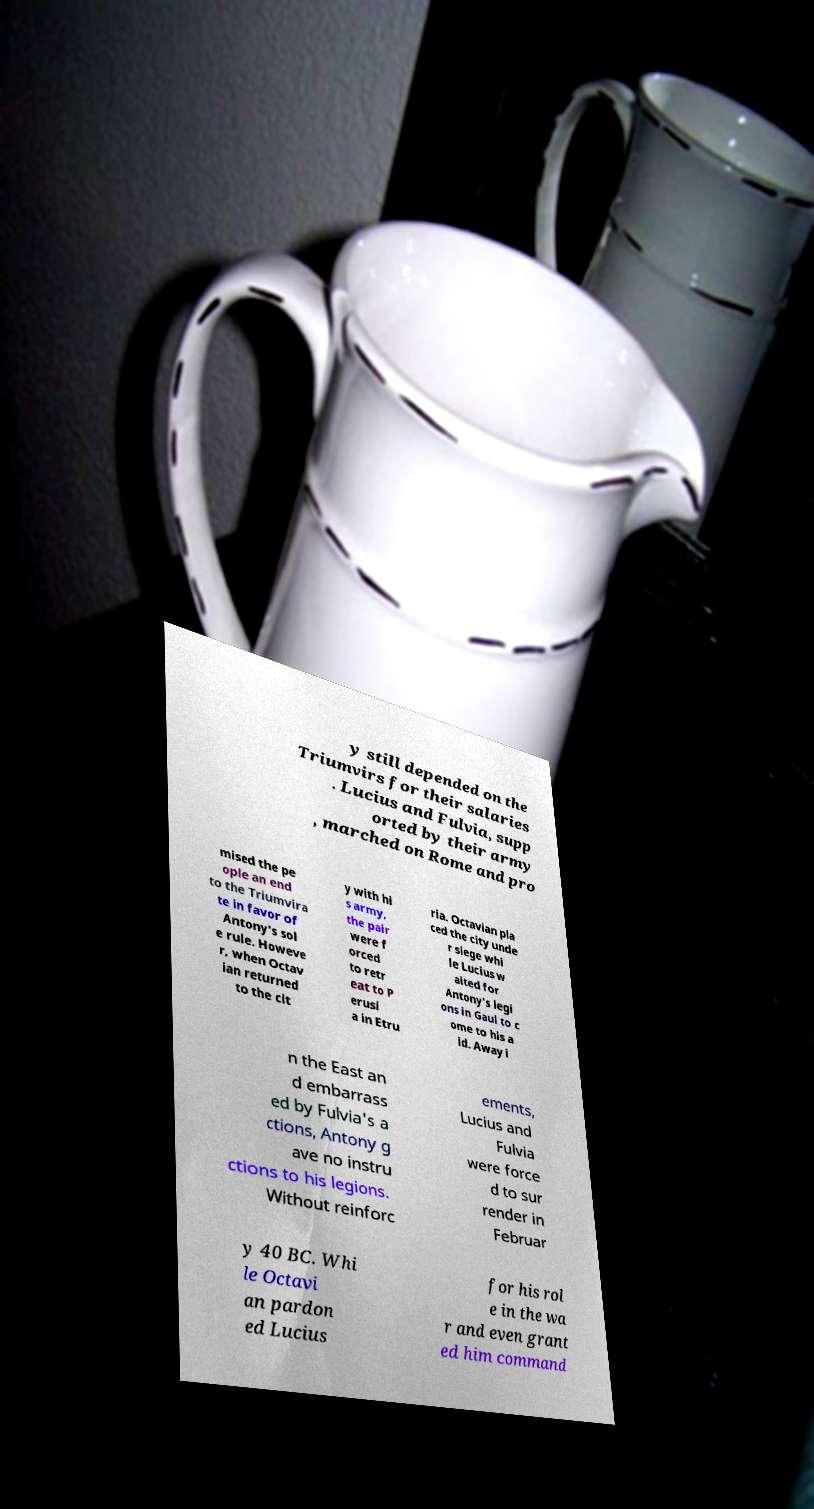Can you read and provide the text displayed in the image?This photo seems to have some interesting text. Can you extract and type it out for me? y still depended on the Triumvirs for their salaries . Lucius and Fulvia, supp orted by their army , marched on Rome and pro mised the pe ople an end to the Triumvira te in favor of Antony's sol e rule. Howeve r, when Octav ian returned to the cit y with hi s army, the pair were f orced to retr eat to P erusi a in Etru ria. Octavian pla ced the city unde r siege whi le Lucius w aited for Antony's legi ons in Gaul to c ome to his a id. Away i n the East an d embarrass ed by Fulvia's a ctions, Antony g ave no instru ctions to his legions. Without reinforc ements, Lucius and Fulvia were force d to sur render in Februar y 40 BC. Whi le Octavi an pardon ed Lucius for his rol e in the wa r and even grant ed him command 